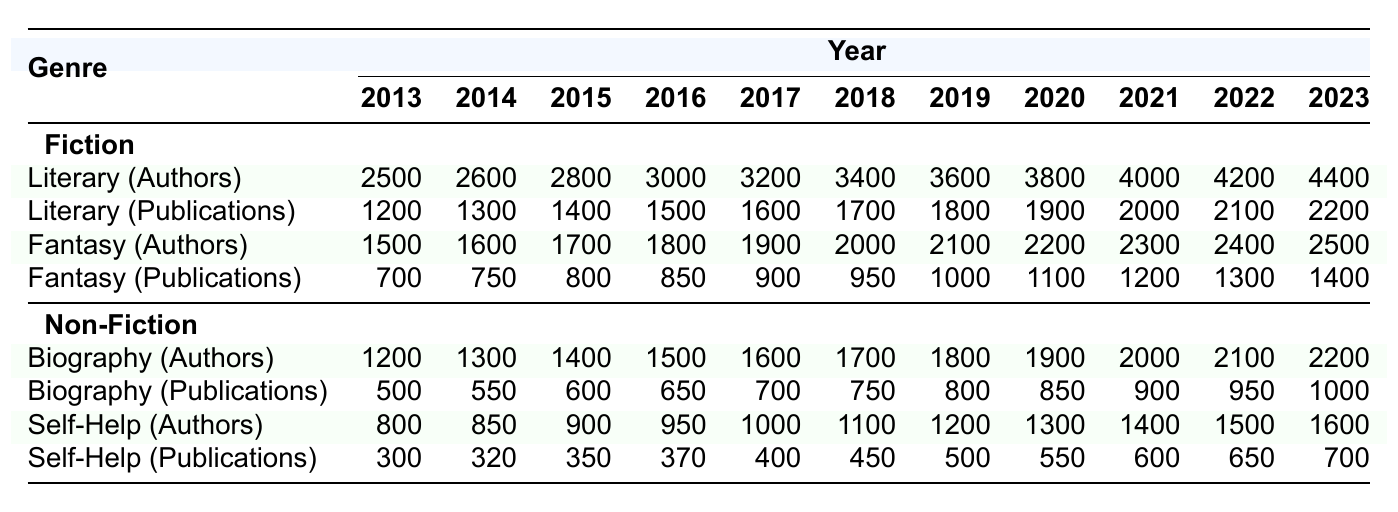What was the total number of author publications in Literary Fiction in 2022? In 2022, the table shows that there were 2100 publications in Literary Fiction.
Answer: 2100 How many authors published in the Fantasy genre in 2018? The table indicates that there were 2000 authors in the Fantasy genre in 2018.
Answer: 2000 Which genre had higher publications in 2023: Biography or Literary Fiction? In 2023, Biography had 1000 publications, while Literary Fiction had 2200 publications. Since 2200 is greater than 1000, Literary Fiction had higher publications.
Answer: Literary Fiction What is the total number of authors in Fiction across all subgenres in 2019? In 2019, the Literary subgenre had 3600 authors, and the Fantasy subgenre had 2100 authors. Summing these gives 3600 + 2100 = 5700 authors in Fiction for 2019.
Answer: 5700 Did the number of authors in Self-Help increase every year from 2013 to 2023? The table indicates that the number of authors in Self-Help increased from 800 in 2013 to 1600 in 2023, confirming an upward trend each year.
Answer: Yes What was the average number of publications in the Biography subgenre over the last decade (2013-2023)? The number of publications per year for Biography is: 500, 550, 600, 650, 700, 750, 800, 850, 900, 950, 1000. The total is 500 + 550 + 600 + 650 + 700 + 750 + 800 + 850 + 900 + 950 + 1000 = 10500. To find the average, divide 10500 by 11, which is approximately 954.5.
Answer: Approximately 954.5 In which year did the number of authors in Literary Fiction surpass 3000? According to the table, Literary Fiction had 3000 authors in 2016. Therefore, it surpassed 3000 for the first time in the year 2016.
Answer: 2016 How many more authors were there in the Fantasy genre compared to the Biography genre in 2020? In 2020, there were 2200 authors in Fantasy and 1900 in Biography. The difference is 2200 - 1900 = 300, indicating there were 300 more authors in Fantasy.
Answer: 300 What is the trend for authors in the Self-Help genre from 2013 to 2023? The values in the Self-Help genre are consistently increasing from 800 in 2013 to 1600 in 2023, indicating a positive trend over the decade.
Answer: Positive trend 